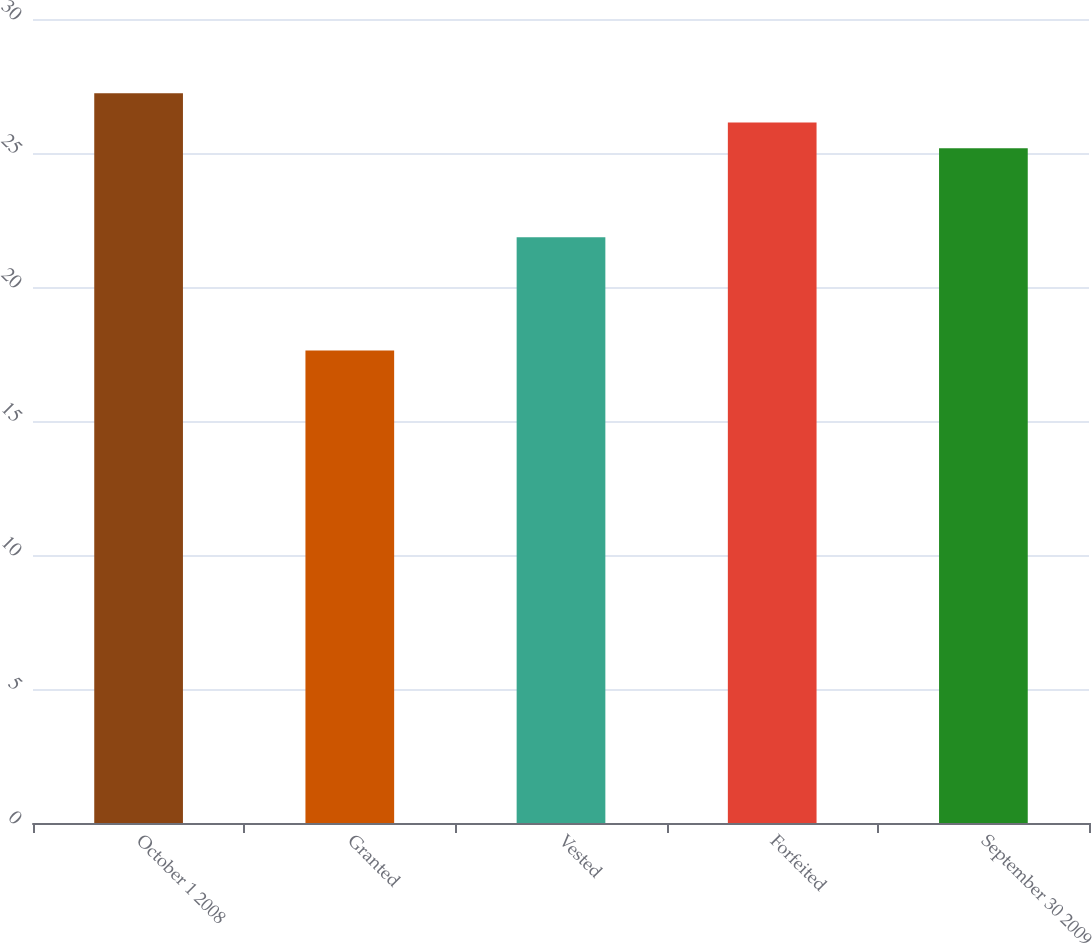Convert chart. <chart><loc_0><loc_0><loc_500><loc_500><bar_chart><fcel>October 1 2008<fcel>Granted<fcel>Vested<fcel>Forfeited<fcel>September 30 2009<nl><fcel>27.23<fcel>17.63<fcel>21.86<fcel>26.14<fcel>25.18<nl></chart> 